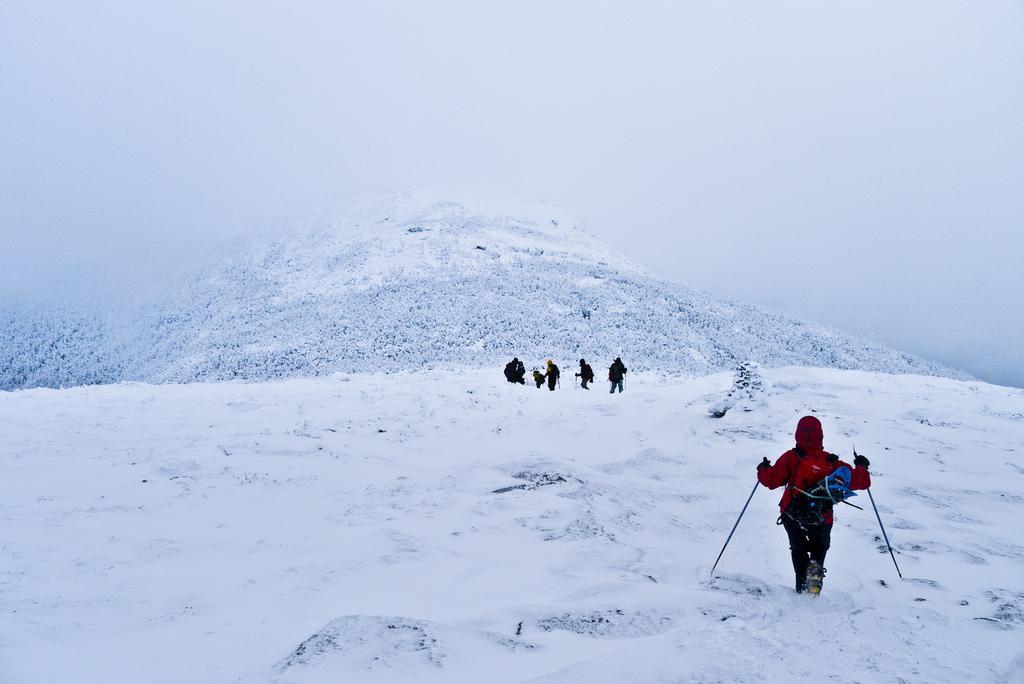How would you summarize this image in a sentence or two? The girl on the right corner of the picture wearing red jacket and backpack is skiing. In front of her, we see people skiing. At the bottom of the picture, we see ice and at the top of the picture, we see the sky. In the background, we see a hill which is covered with ice. 